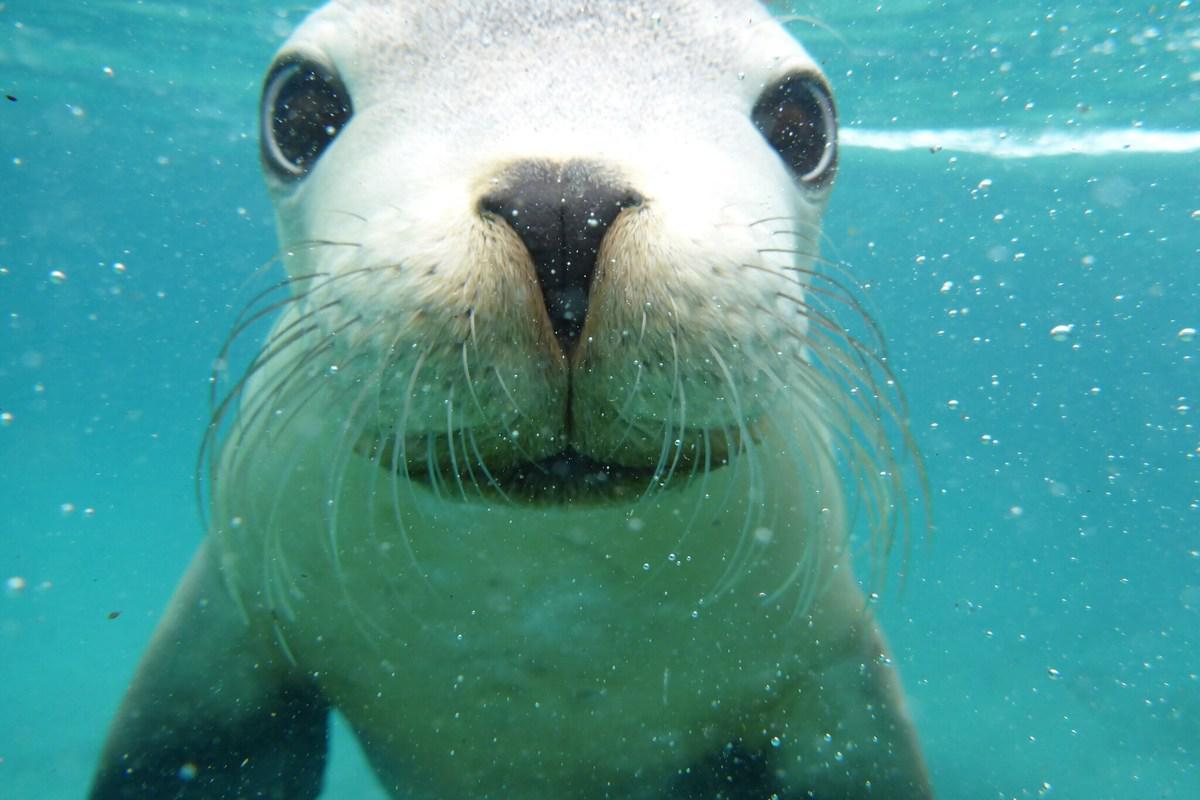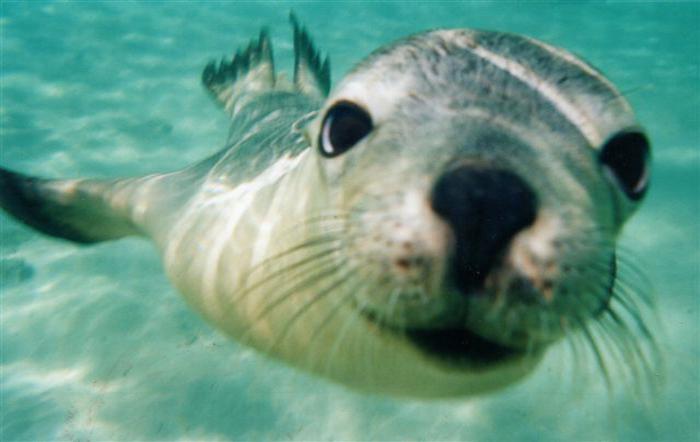The first image is the image on the left, the second image is the image on the right. Analyze the images presented: Is the assertion "In at least one image there is a sea lion swimming alone with no other mammals present." valid? Answer yes or no. Yes. The first image is the image on the left, the second image is the image on the right. For the images displayed, is the sentence "The left image shows a diver in a wetsuit interacting with a seal, but the right image does not include a diver." factually correct? Answer yes or no. No. 